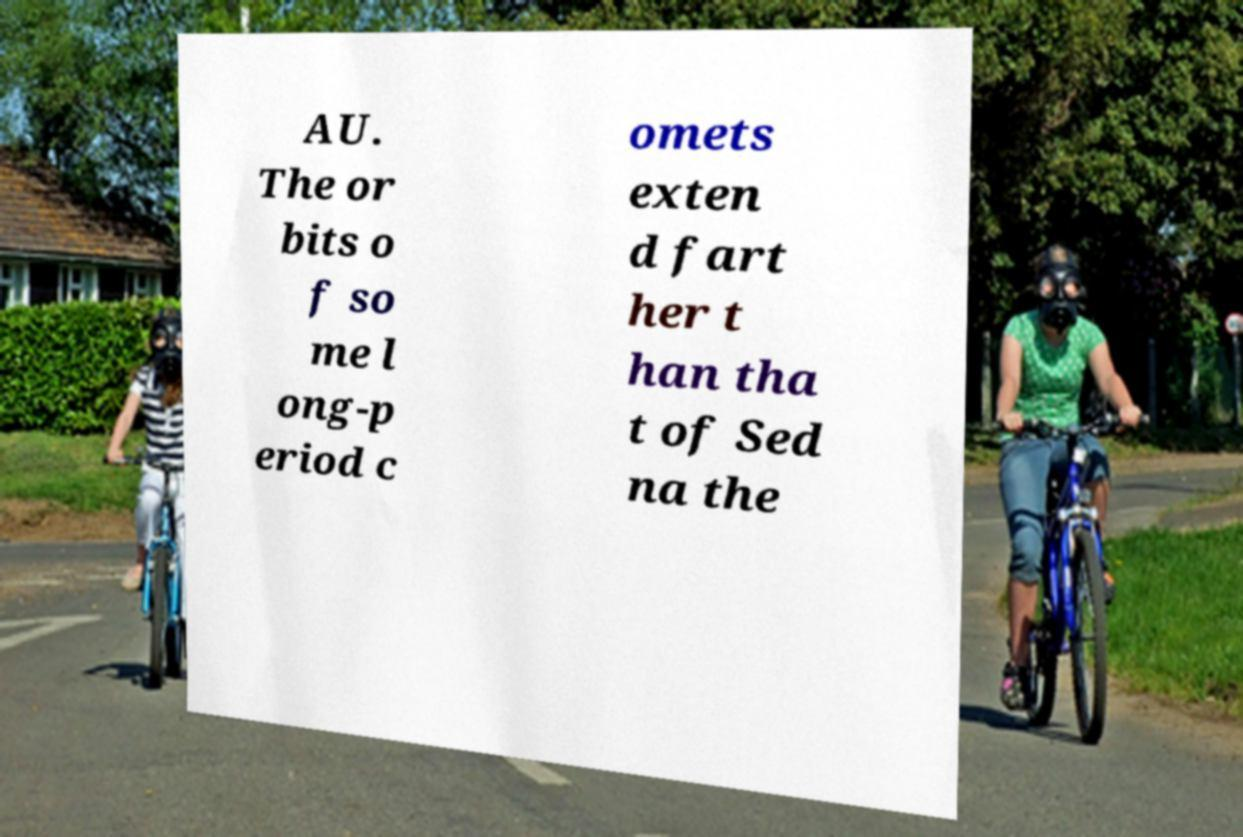Can you accurately transcribe the text from the provided image for me? AU. The or bits o f so me l ong-p eriod c omets exten d fart her t han tha t of Sed na the 